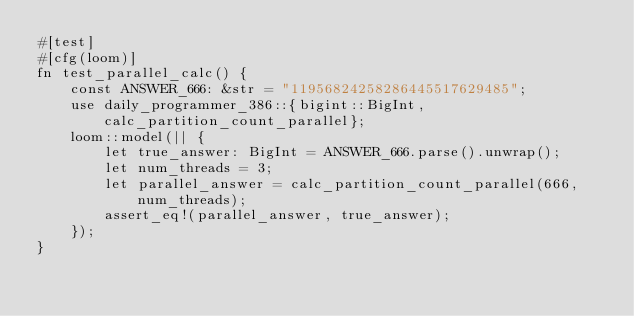<code> <loc_0><loc_0><loc_500><loc_500><_Rust_>#[test]
#[cfg(loom)]
fn test_parallel_calc() {
    const ANSWER_666: &str = "11956824258286445517629485";
    use daily_programmer_386::{bigint::BigInt, calc_partition_count_parallel};
    loom::model(|| {
        let true_answer: BigInt = ANSWER_666.parse().unwrap();
        let num_threads = 3;
        let parallel_answer = calc_partition_count_parallel(666, num_threads);
        assert_eq!(parallel_answer, true_answer);
    });
}
</code> 